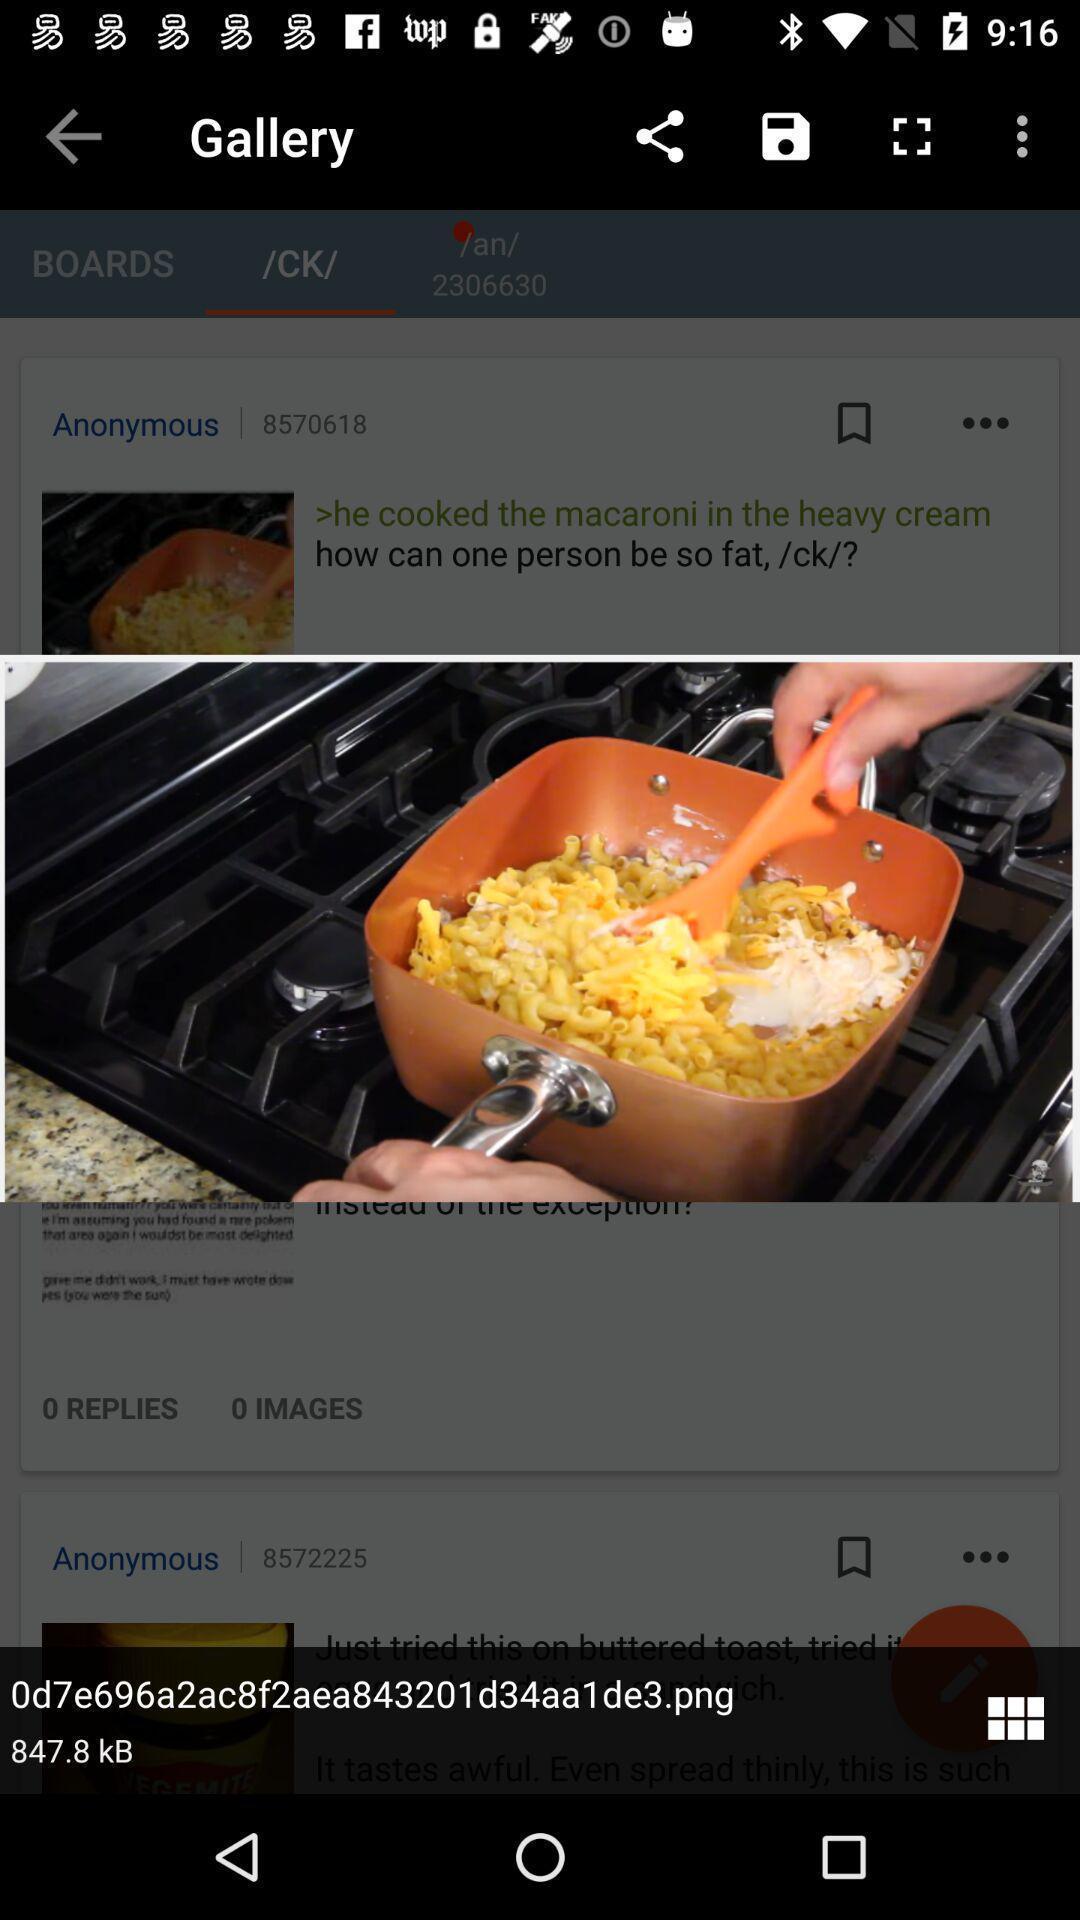Give me a narrative description of this picture. Pop-up displaying with a image. 